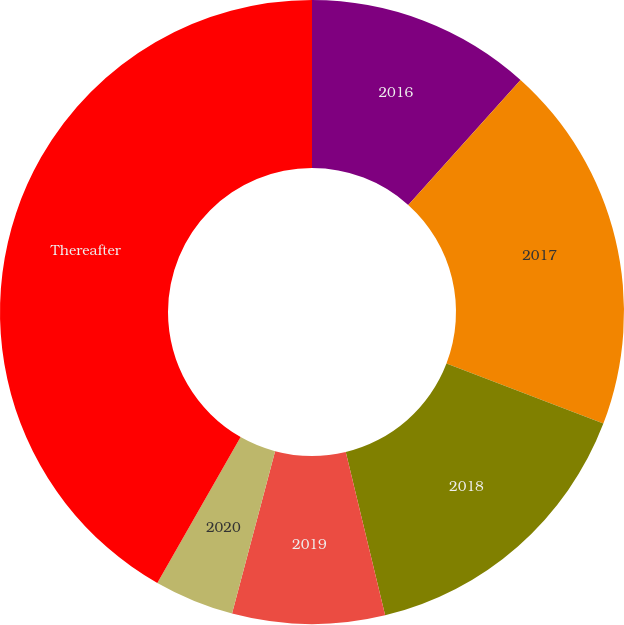Convert chart. <chart><loc_0><loc_0><loc_500><loc_500><pie_chart><fcel>2016<fcel>2017<fcel>2018<fcel>2019<fcel>2020<fcel>Thereafter<nl><fcel>11.65%<fcel>19.17%<fcel>15.41%<fcel>7.89%<fcel>4.13%<fcel>41.74%<nl></chart> 